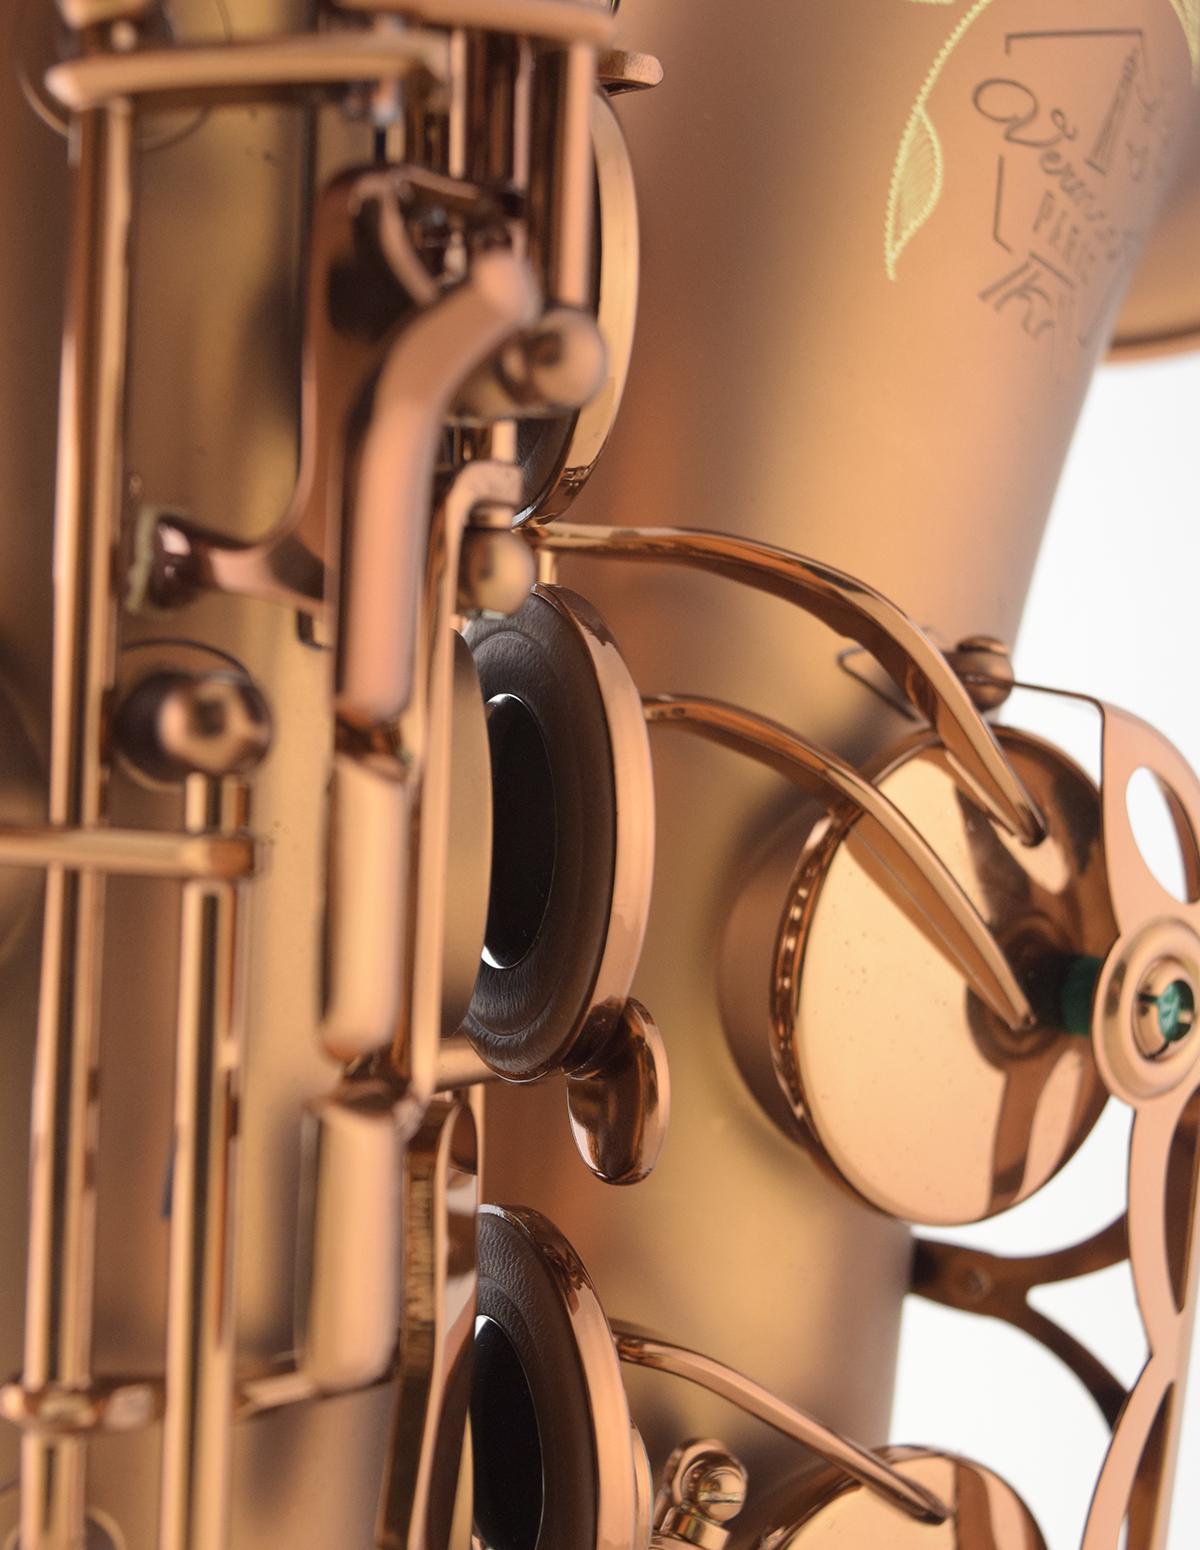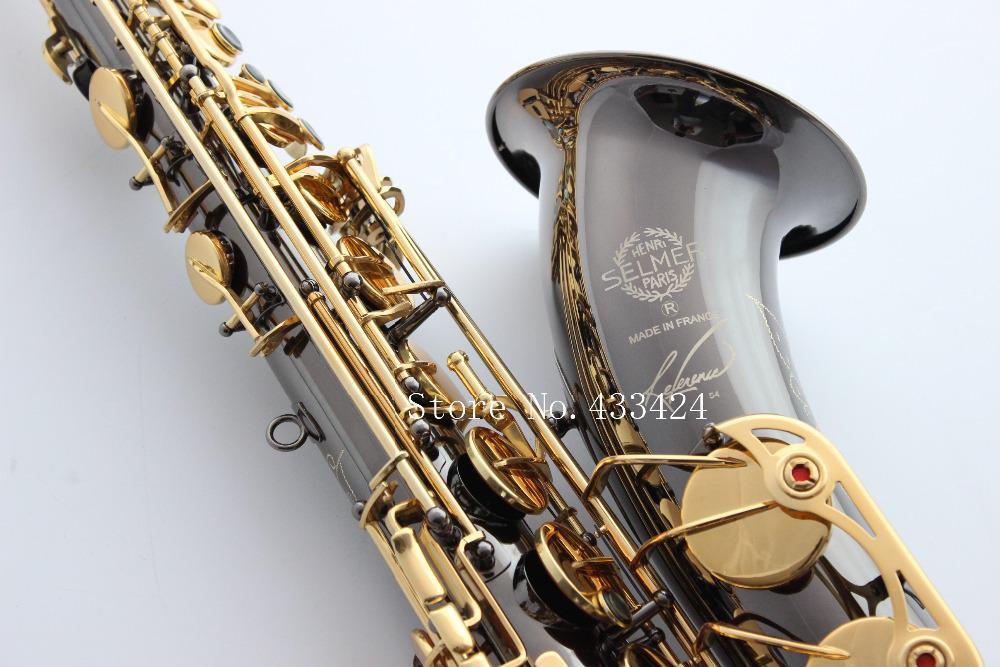The first image is the image on the left, the second image is the image on the right. For the images shown, is this caption "An image includes more than one saxophone." true? Answer yes or no. No. 